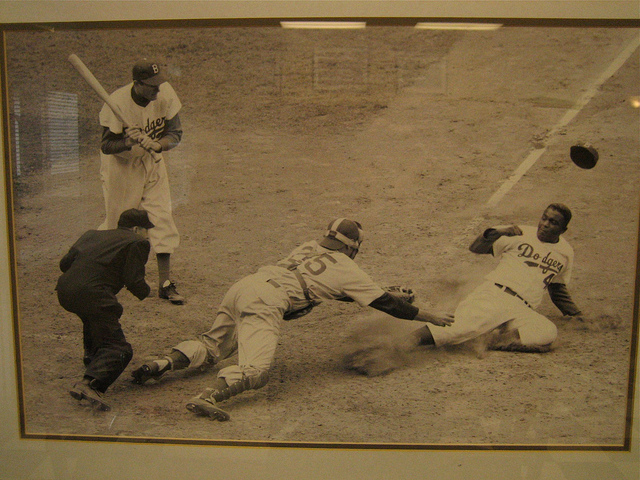<image>Is he going to catch it? It's ambiguous whether he is going to catch it or not. Is he going to catch it? I don't know if he is going to catch it. It is ambiguous. 